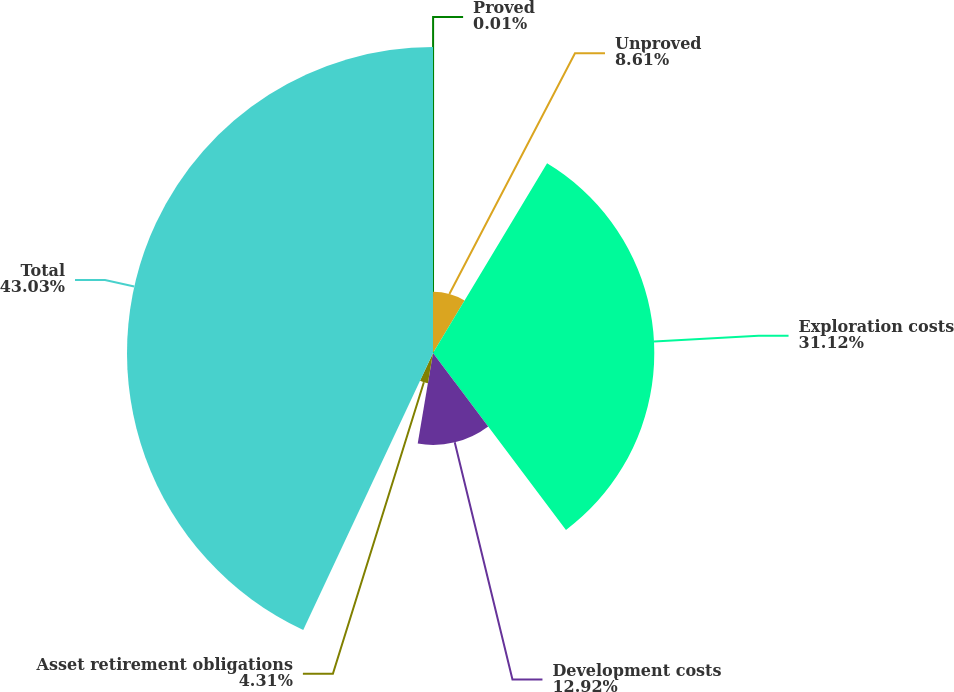Convert chart. <chart><loc_0><loc_0><loc_500><loc_500><pie_chart><fcel>Proved<fcel>Unproved<fcel>Exploration costs<fcel>Development costs<fcel>Asset retirement obligations<fcel>Total<nl><fcel>0.01%<fcel>8.61%<fcel>31.12%<fcel>12.92%<fcel>4.31%<fcel>43.03%<nl></chart> 